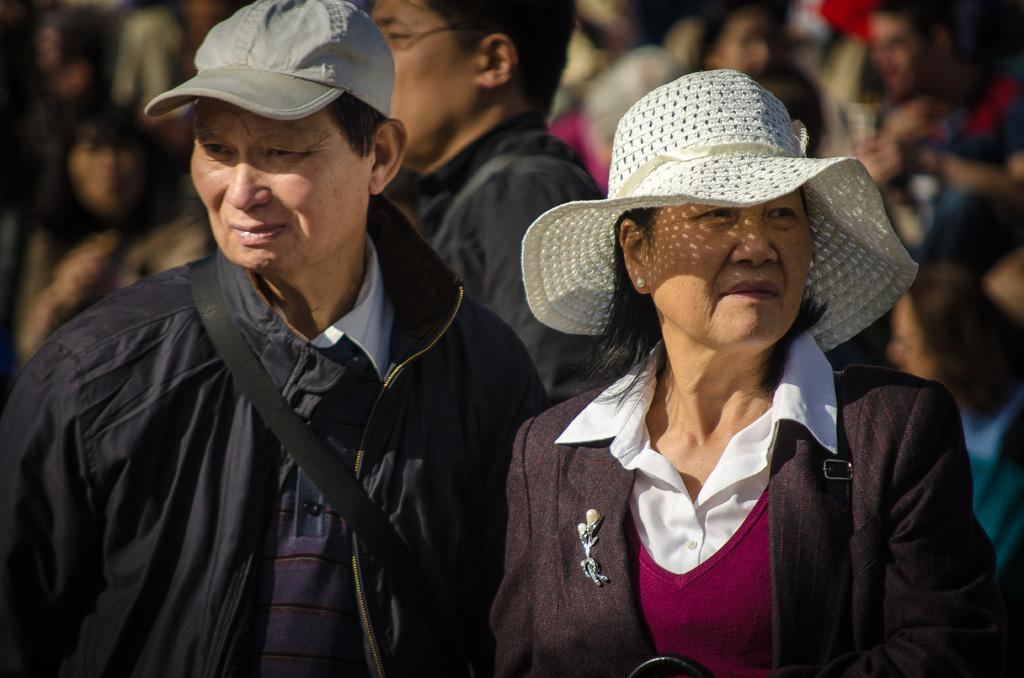How many people are present in the image? There are three people standing in the image. Can you describe the people in the image? Unfortunately, the provided facts do not give any information about the appearance or characteristics of the people. Are there any other people visible in the image? Yes, there are blurred people visible in the background of the image. What type of polish is being applied to the chicken's brain in the image? There is no chicken or brain present in the image, and therefore no polish is being applied. 